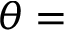<formula> <loc_0><loc_0><loc_500><loc_500>\theta =</formula> 